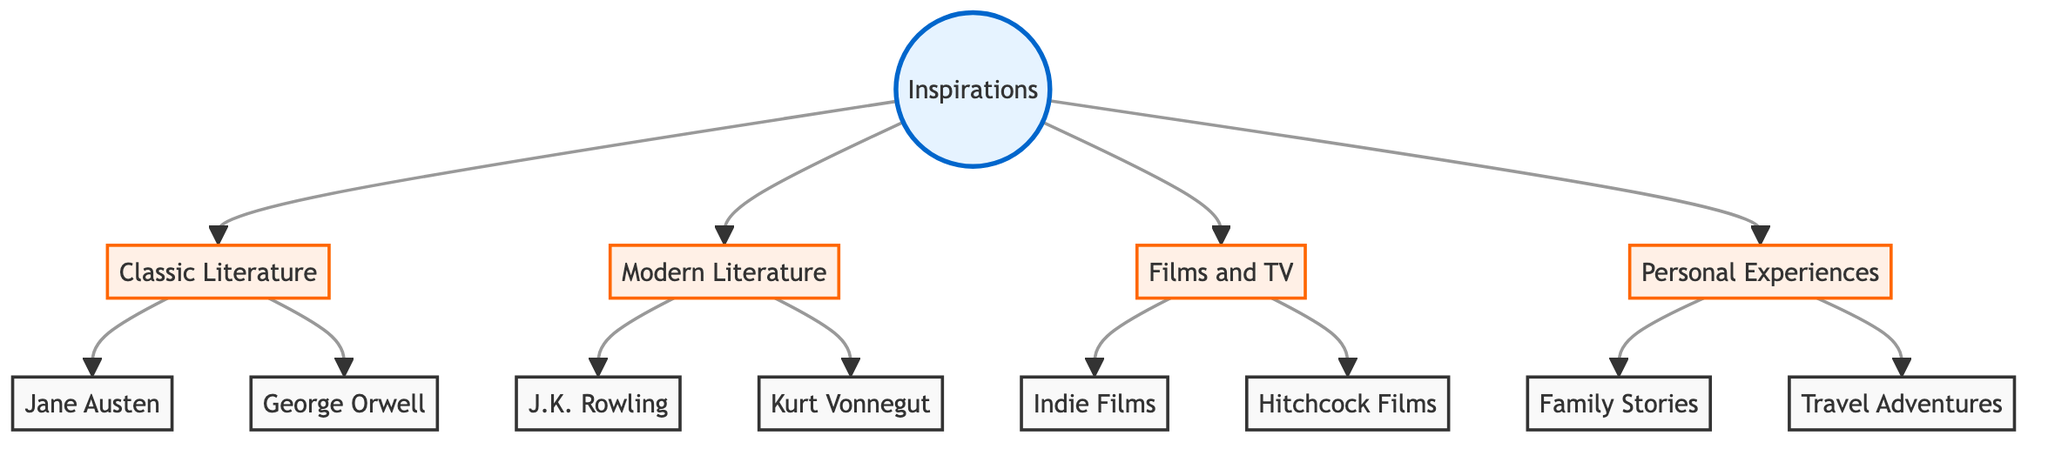What is the total number of nodes in the diagram? To find the total number of nodes, we count each unique node listed in the "nodes" section of the diagram. There are 13 unique nodes: Inspirations, Classic Literature, Modern Literature, Films and TV, Personal Experiences, Jane Austen, George Orwell, J.K. Rowling, Kurt Vonnegut, Indie Films, Hitchcock Films, Family Stories, and Travel Adventures.
Answer: 13 Which two categories are influenced by personal experiences? By examining the edges connected to the node "personal_experiences," we see that it points to two nodes: family_stories and travel_adventures. Therefore, these are the two categories influenced by personal experiences.
Answer: Family Stories, Travel Adventures Who is the author associated with modern literature? In the "modern_literature" node, there are two edges leading to the authors listed: one to "j_k_rowling" and the other to "kurt_vonnegut." Therefore, both authors are associated with modern literature.
Answer: J.K. Rowling, Kurt Vonnegut How many categories influence the main inspirations? The "inspirations" node has four outgoing edges connecting to other nodes: classic_literature, modern_literature, films_and_tv, and personal_experiences. Thus, there are four categories that influence the main inspirations.
Answer: 4 Which classic literature authors are mentioned in the diagram? The "classic_literature" node connects to two authors: "jane_austen" and "george_orwell." Thus, these are the classic literature authors highlighted in the diagram.
Answer: Jane Austen, George Orwell What type of media is influenced by the films and TV category? From the "films_and_tv" node, there are edges pointing to "indie_films" and "hitchcock_films." This shows that both types of media are influenced by films and TV.
Answer: Indie Films, Hitchcock Films Which node represents personal stories, and how many are there? The "personal_experiences" node connects to two other nodes: family_stories and travel_adventures, representing personal stories in this context. Therefore, there are two nodes representing personal stories.
Answer: 2 Which nodes are directly influenced by classic literature? The "classic_literature" node has edges pointing to two nodes: "jane_austen" and "george_orwell," indicating that these authors are directly influenced by classic literature.
Answer: Jane Austen, George Orwell 